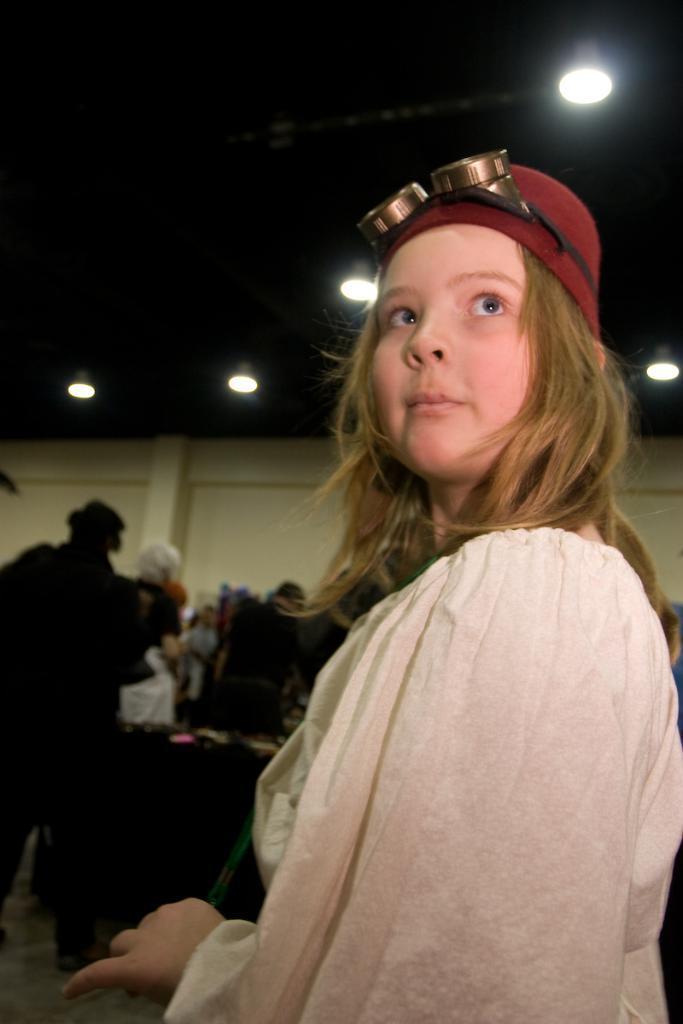Can you describe this image briefly? In this picture we can see a small girl standing in the front and looking on the top. Behind we can see some persons standing near the table. In the background there is a white color wall and some spot lights on the ceiling. 